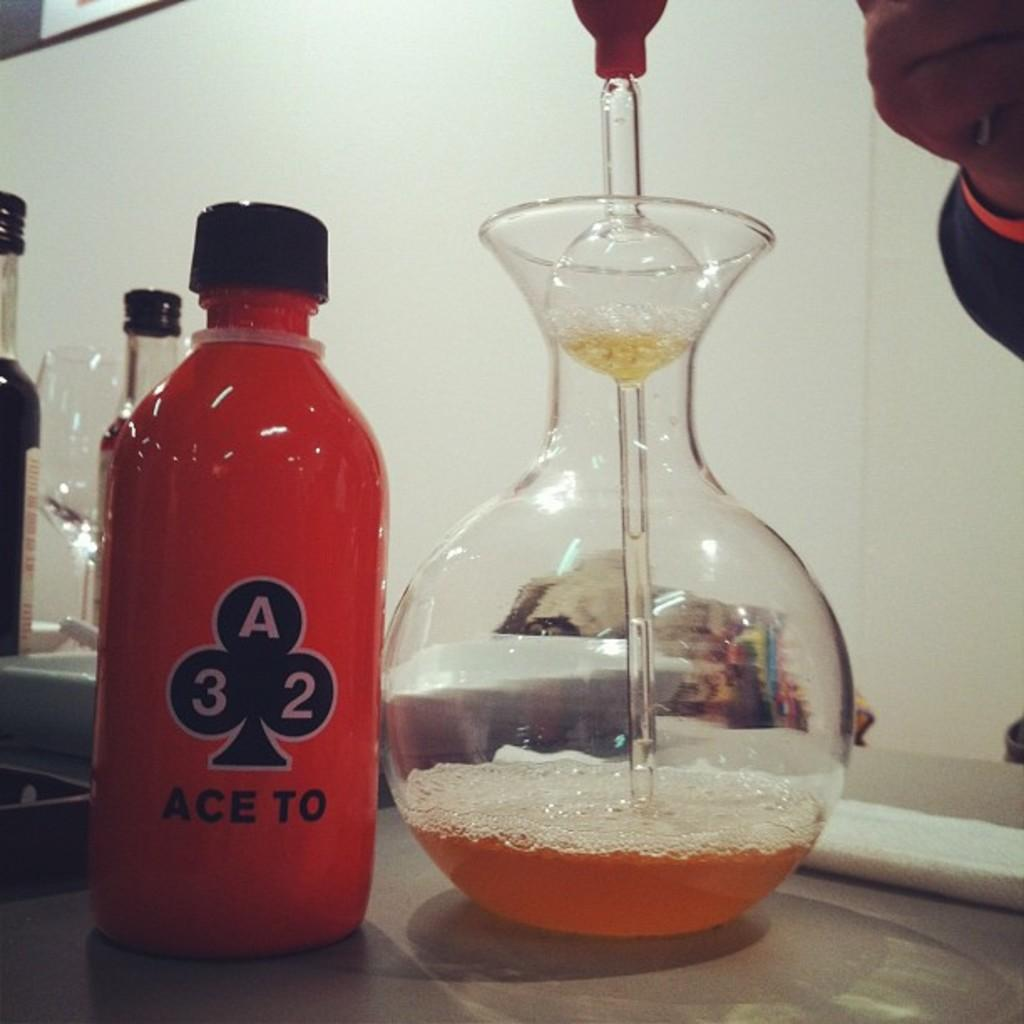What is present on the table in the image? There is a bottle and a glass on the table in the image. What can be inferred about the purpose of the bottle and the glass? Both the bottle and the glass are likely used for holding or serving a beverage. What type of beast can be seen drinking from the glass in the image? There is no beast present in the image, and therefore no such activity can be observed. 